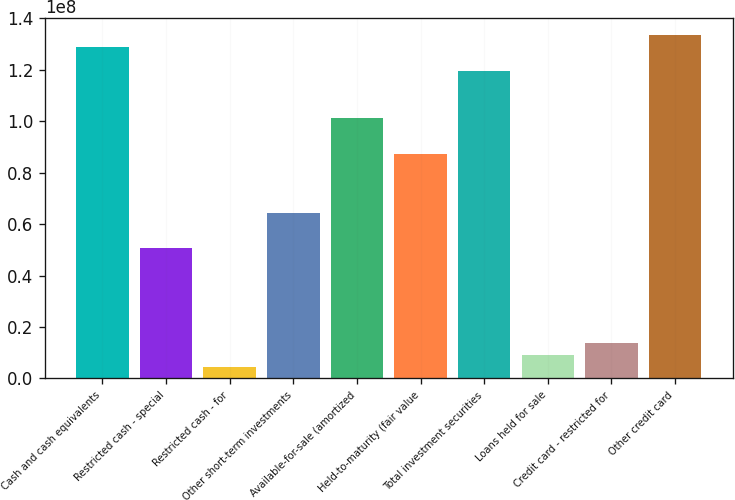<chart> <loc_0><loc_0><loc_500><loc_500><bar_chart><fcel>Cash and cash equivalents<fcel>Restricted cash - special<fcel>Restricted cash - for<fcel>Other short-term investments<fcel>Available-for-sale (amortized<fcel>Held-to-maturity (fair value<fcel>Total investment securities<fcel>Loans held for sale<fcel>Credit card - restricted for<fcel>Other credit card<nl><fcel>1.28859e+08<fcel>5.06231e+07<fcel>4.6021e+06<fcel>6.44294e+07<fcel>1.01246e+08<fcel>8.74399e+07<fcel>1.19655e+08<fcel>9.2042e+06<fcel>1.38063e+07<fcel>1.33461e+08<nl></chart> 